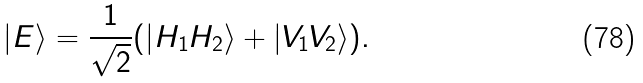<formula> <loc_0><loc_0><loc_500><loc_500>| E \rangle = \frac { 1 } { \sqrt { 2 } } ( | H _ { 1 } H _ { 2 } \rangle + | V _ { 1 } V _ { 2 } \rangle ) .</formula> 